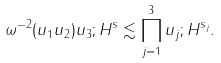<formula> <loc_0><loc_0><loc_500><loc_500>\| \omega ^ { - 2 } ( u _ { 1 } u _ { 2 } ) u _ { 3 } ; H ^ { s } \| \lesssim \prod _ { j = 1 } ^ { 3 } \| u _ { j } ; H ^ { s _ { j } } \| .</formula> 